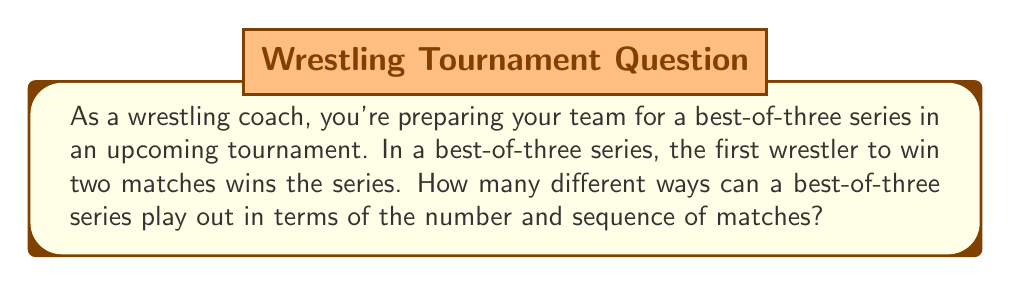Teach me how to tackle this problem. Let's approach this step-by-step:

1) First, we need to consider the possible outcomes of a best-of-three series:

   - The series could end in 2 matches (if one wrestler wins both)
   - The series could go to 3 matches (if each wrestler wins one of the first two)

2) For a 2-match series:
   - We can have Win-Win (WW)
   - There are 2 ways this can happen: Wrestler A wins both, or Wrestler B wins both

3) For a 3-match series:
   - We can have Win-Loss-Win (WLW) or Loss-Win-Win (LWW)
   - There are 2 ways this can happen for each wrestler

4) Let's count the total number of possibilities:
   - 2-match series: 2 possibilities
   - 3-match series: 4 possibilities (2 for each wrestler)

5) Total number of possibilities: $2 + 4 = 6$

We can represent this mathematically as:

$$\text{Total Possibilities} = \binom{2}{2} \cdot 2 + \binom{3}{2} \cdot 2 = 2 + 4 = 6$$

Where $\binom{2}{2}$ represents choosing 2 wins out of 2 matches, and $\binom{3}{2}$ represents choosing 2 wins out of 3 matches.
Answer: There are 6 different ways a best-of-three series can play out. 